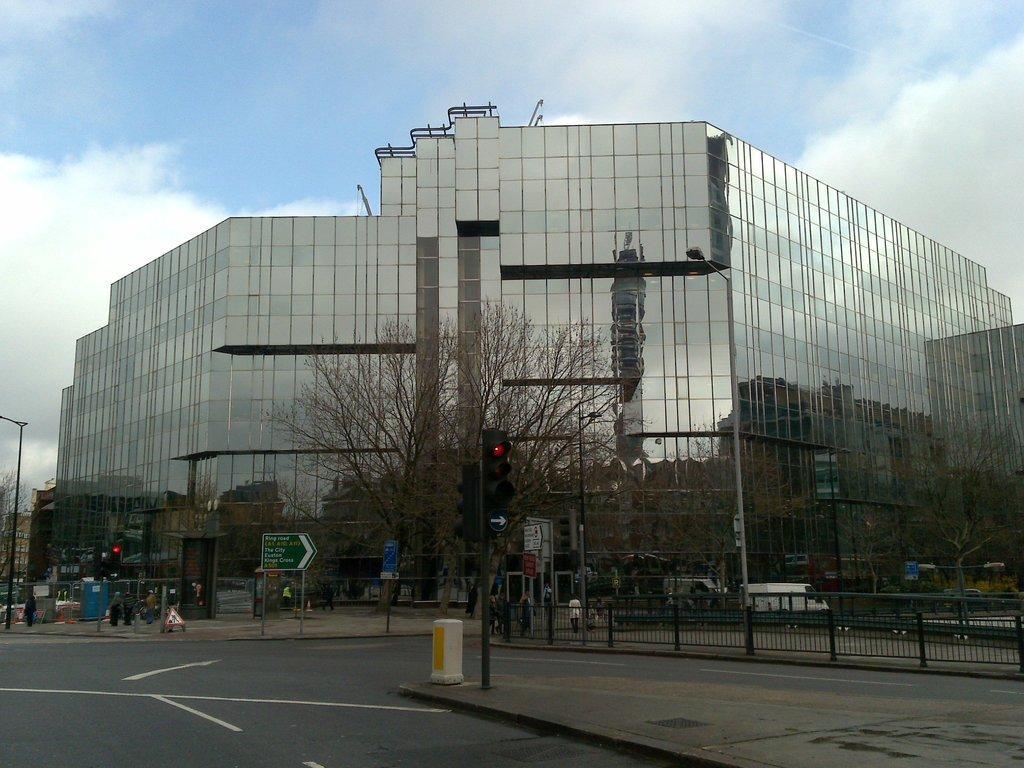Please provide a concise description of this image. In this image in the front there is a signal pole. In the background there is a fence, there are boards with some text written on it, there are trees, poles, persons and there is a building. There are vehicles moving on the road and the sky is cloudy. 